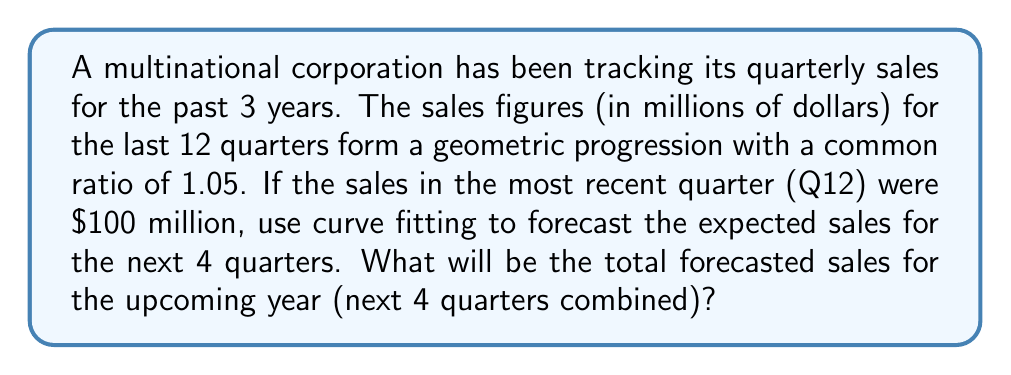Teach me how to tackle this problem. To solve this problem, we'll follow these steps:

1) First, let's identify the geometric progression. We know that:
   - The last term (Q12) is $100 million
   - The common ratio is 1.05

2) In a geometric progression, each term is 1.05 times the previous term. So, we can work backwards to find the first term:

   $a_{12} = 100$
   $a_{11} = 100 / 1.05$
   $a_{10} = 100 / 1.05^2$
   ...
   $a_1 = 100 / 1.05^{11} \approx 57.32$

3) Now that we have the first term, we can use the formula for the nth term of a geometric progression:

   $a_n = a_1 \cdot r^{n-1}$

   Where $a_1$ is the first term, $r$ is the common ratio, and $n$ is the term number.

4) To forecast the next 4 quarters, we'll use this formula for Q13, Q14, Q15, and Q16:

   Q13: $a_{13} = 57.32 \cdot 1.05^{12} = 105$
   Q14: $a_{14} = 57.32 \cdot 1.05^{13} \approx 110.25$
   Q15: $a_{15} = 57.32 \cdot 1.05^{14} \approx 115.76$
   Q16: $a_{16} = 57.32 \cdot 1.05^{15} \approx 121.55$

5) To find the total forecasted sales for the upcoming year, we sum these 4 values:

   Total = 105 + 110.25 + 115.76 + 121.55 = 452.56

Therefore, the total forecasted sales for the upcoming year is approximately $452.56 million.
Answer: $452.56 million 